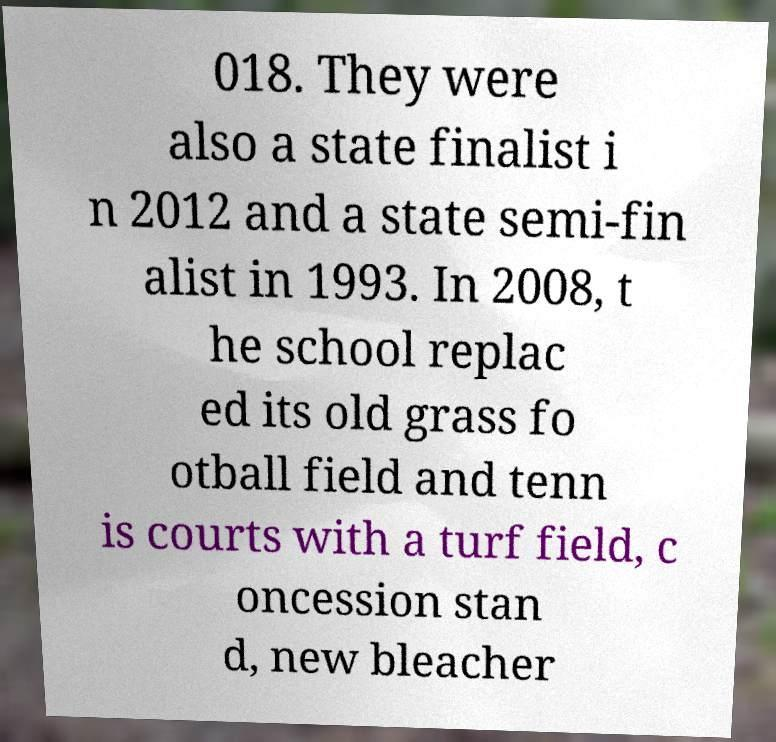Please read and relay the text visible in this image. What does it say? 018. They were also a state finalist i n 2012 and a state semi-fin alist in 1993. In 2008, t he school replac ed its old grass fo otball field and tenn is courts with a turf field, c oncession stan d, new bleacher 